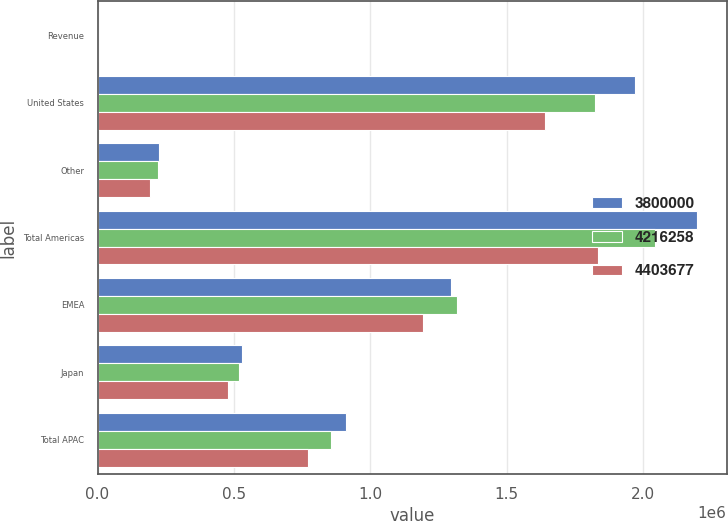Convert chart. <chart><loc_0><loc_0><loc_500><loc_500><stacked_bar_chart><ecel><fcel>Revenue<fcel>United States<fcel>Other<fcel>Total Americas<fcel>EMEA<fcel>Japan<fcel>Total APAC<nl><fcel>3.8e+06<fcel>2012<fcel>1.96992e+06<fcel>226430<fcel>2.19635e+06<fcel>1.29457e+06<fcel>531028<fcel>912757<nl><fcel>4.21626e+06<fcel>2011<fcel>1.8232e+06<fcel>221399<fcel>2.0446e+06<fcel>1.31742e+06<fcel>517378<fcel>854237<nl><fcel>4.40368e+06<fcel>2010<fcel>1.64198e+06<fcel>193309<fcel>1.83529e+06<fcel>1.19195e+06<fcel>477462<fcel>772760<nl></chart> 